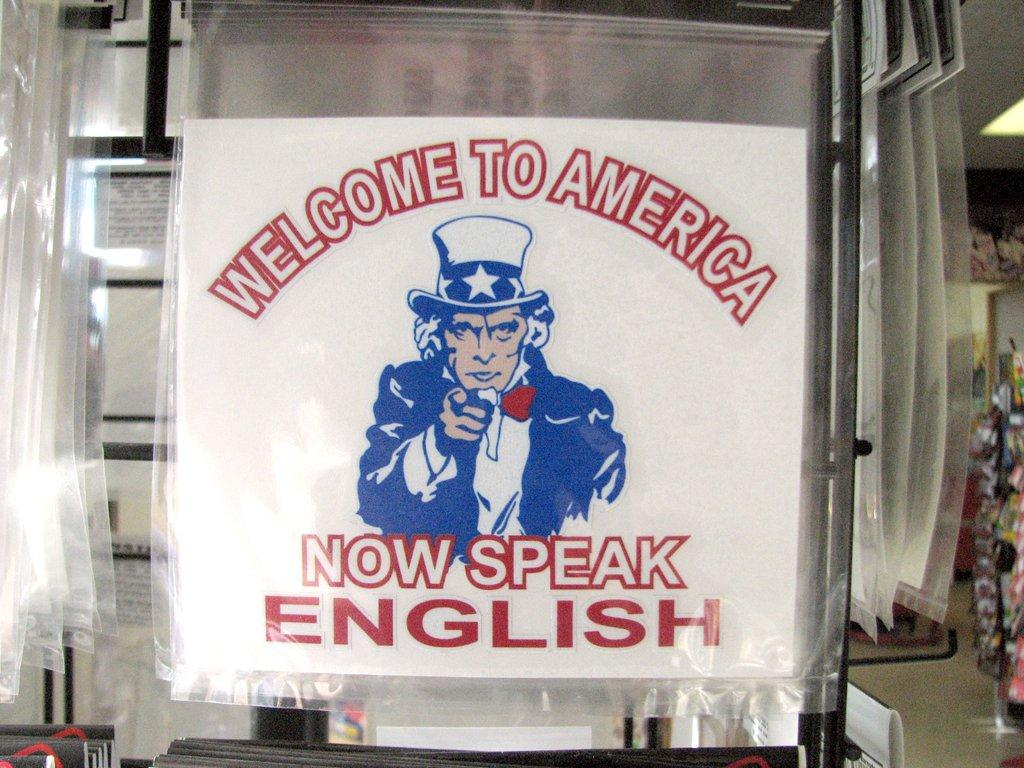<image>
Give a short and clear explanation of the subsequent image. Sign on a wall that says Welcome to America, Now Speak English. 